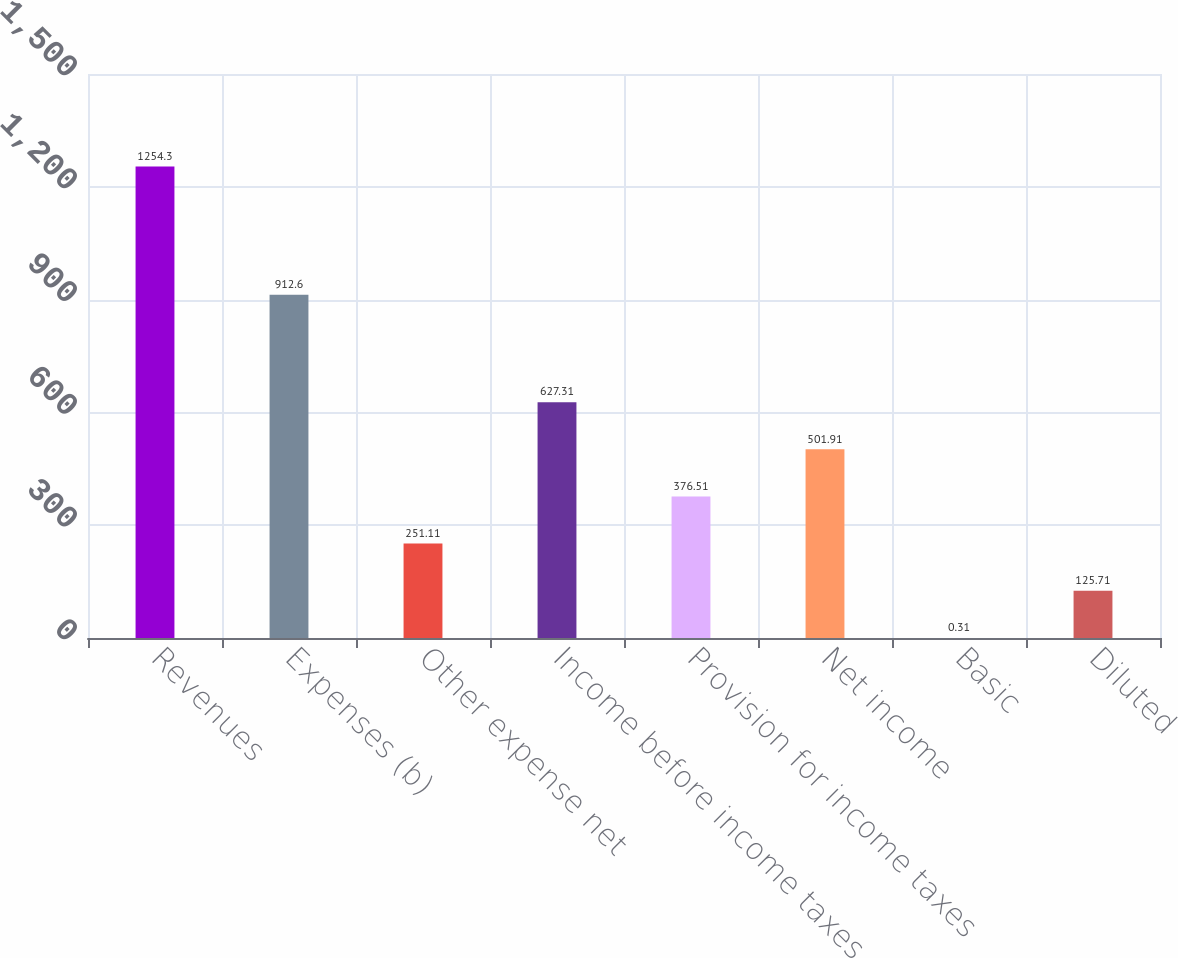Convert chart to OTSL. <chart><loc_0><loc_0><loc_500><loc_500><bar_chart><fcel>Revenues<fcel>Expenses (b)<fcel>Other expense net<fcel>Income before income taxes<fcel>Provision for income taxes<fcel>Net income<fcel>Basic<fcel>Diluted<nl><fcel>1254.3<fcel>912.6<fcel>251.11<fcel>627.31<fcel>376.51<fcel>501.91<fcel>0.31<fcel>125.71<nl></chart> 